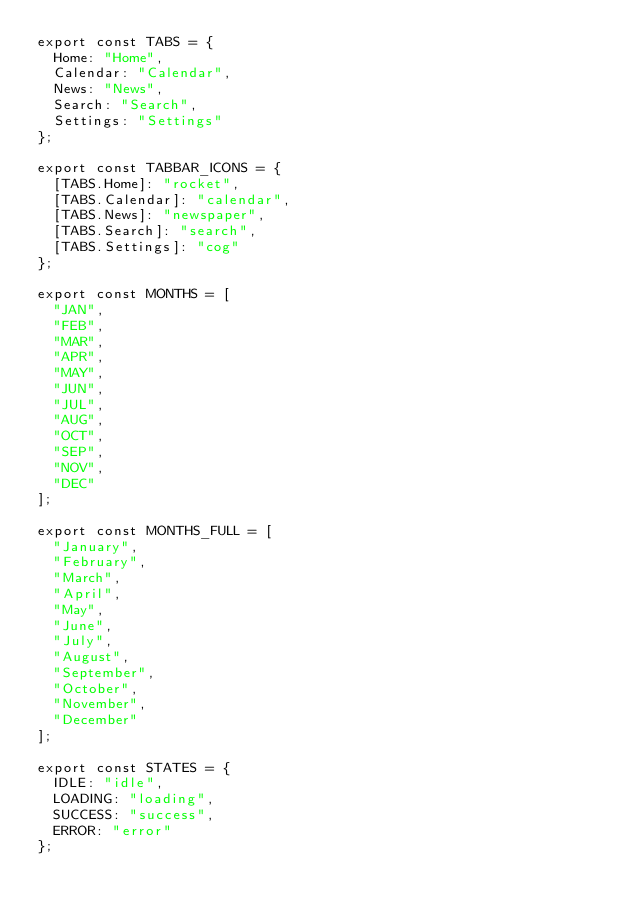Convert code to text. <code><loc_0><loc_0><loc_500><loc_500><_JavaScript_>export const TABS = {
  Home: "Home",
  Calendar: "Calendar",
  News: "News",
  Search: "Search",
  Settings: "Settings"
};

export const TABBAR_ICONS = {
  [TABS.Home]: "rocket",
  [TABS.Calendar]: "calendar",
  [TABS.News]: "newspaper",
  [TABS.Search]: "search",
  [TABS.Settings]: "cog"
};

export const MONTHS = [
  "JAN",
  "FEB",
  "MAR",
  "APR",
  "MAY",
  "JUN",
  "JUL",
  "AUG",
  "OCT",
  "SEP",
  "NOV",
  "DEC"
];

export const MONTHS_FULL = [
  "January",
  "February",
  "March",
  "April",
  "May",
  "June",
  "July",
  "August",
  "September",
  "October",
  "November",
  "December"
];

export const STATES = {
  IDLE: "idle",
  LOADING: "loading",
  SUCCESS: "success",
  ERROR: "error"
};
</code> 